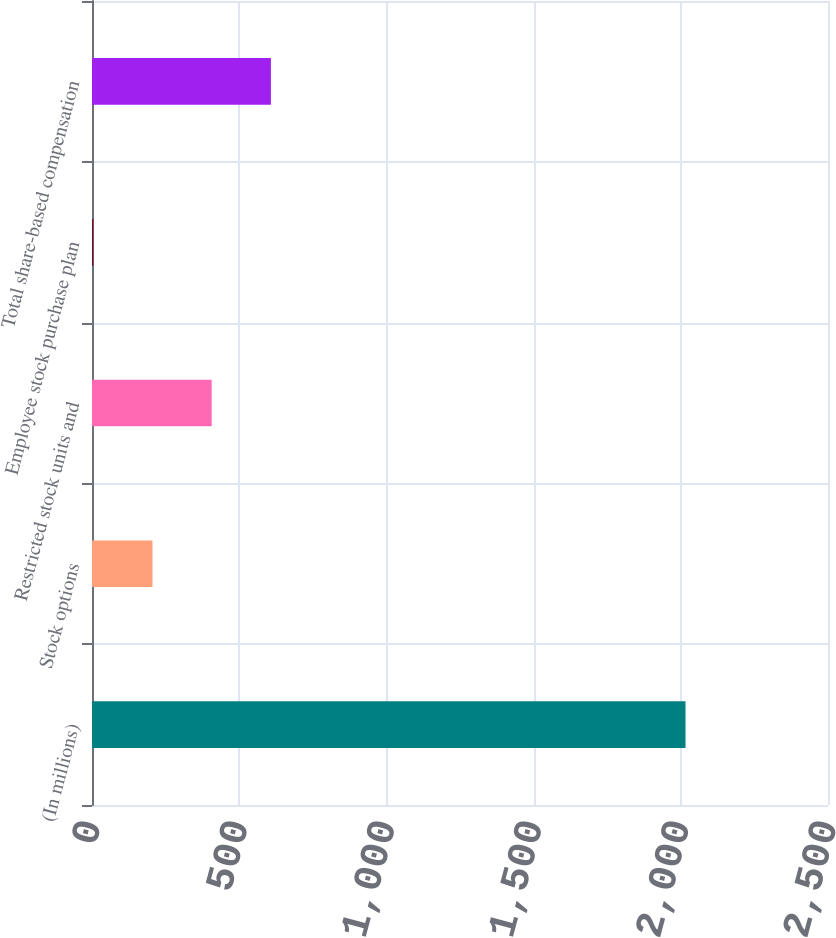<chart> <loc_0><loc_0><loc_500><loc_500><bar_chart><fcel>(In millions)<fcel>Stock options<fcel>Restricted stock units and<fcel>Employee stock purchase plan<fcel>Total share-based compensation<nl><fcel>2016<fcel>205.38<fcel>406.56<fcel>4.2<fcel>607.74<nl></chart> 